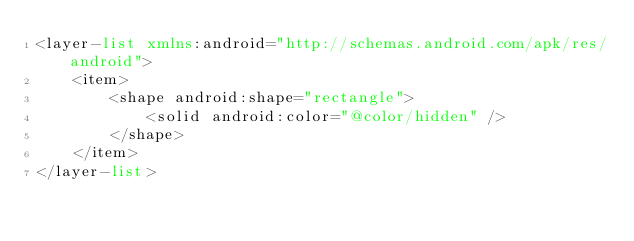<code> <loc_0><loc_0><loc_500><loc_500><_XML_><layer-list xmlns:android="http://schemas.android.com/apk/res/android">
    <item>
        <shape android:shape="rectangle">
            <solid android:color="@color/hidden" />
        </shape>
    </item>
</layer-list></code> 